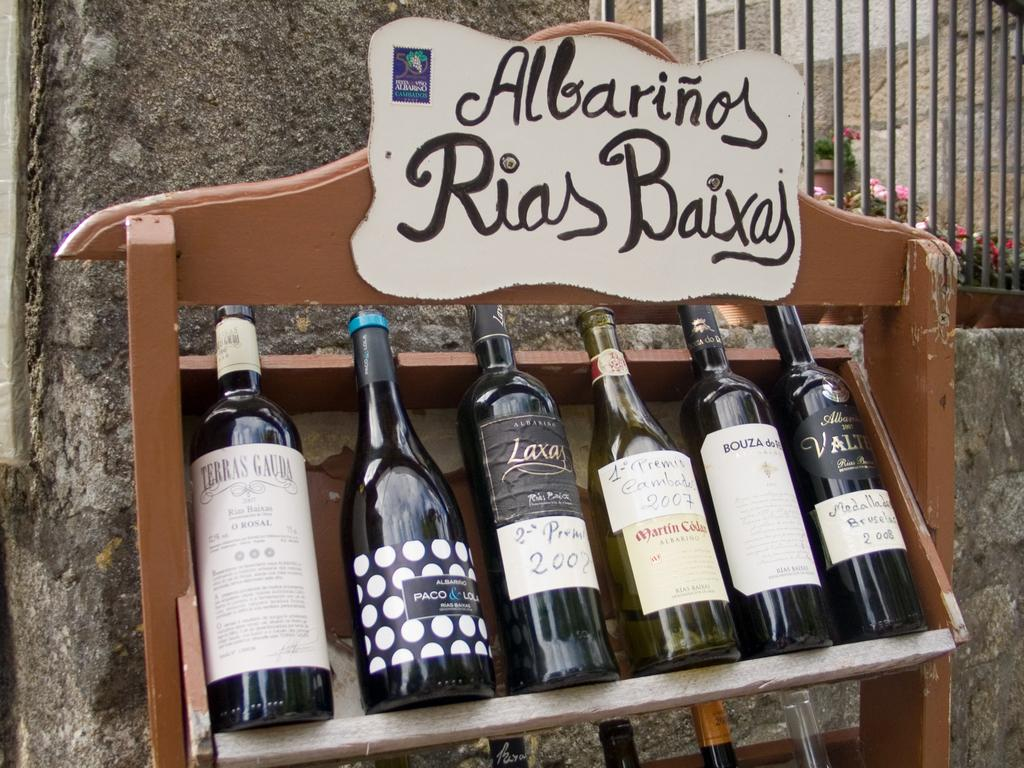<image>
Describe the image concisely. A sign says "Albarinos Rias Baixas" above some bottles of wine. 